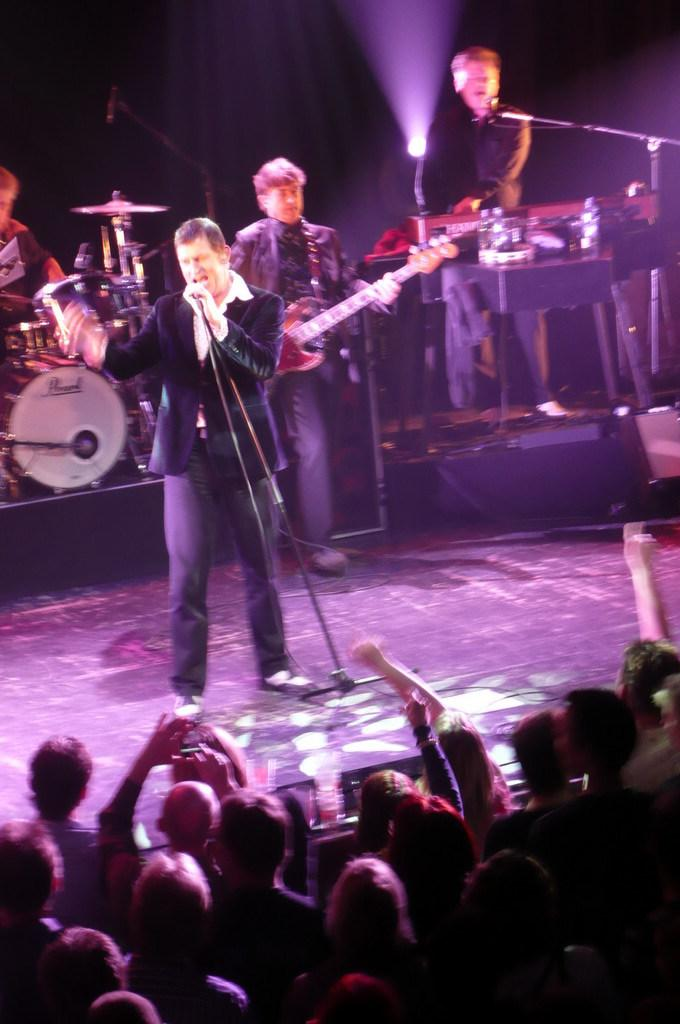What is happening on the stage in the image? There are people standing on stage, suggesting a performance or event. Who might be observing the stage? There are people looking at the stage, indicating an audience. What musical instruments are present on the stage? There are drums, a microphone, and a guitar on the stage. What time of day is it in the image, based on the hour hand of the clock on stage? There is no clock or hour hand present in the image, so we cannot determine the time of day. What type of spark can be seen coming from the guitar in the image? There is no spark visible in the image; the guitar is not shown in use. 